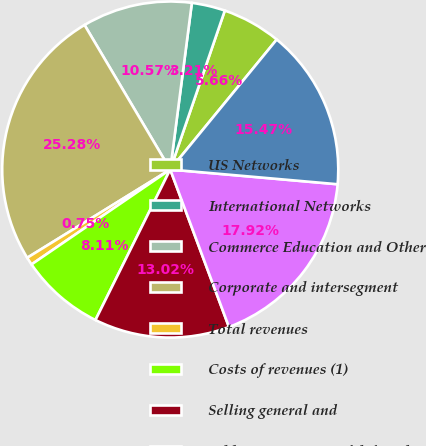<chart> <loc_0><loc_0><loc_500><loc_500><pie_chart><fcel>US Networks<fcel>International Networks<fcel>Commerce Education and Other<fcel>Corporate and intersegment<fcel>Total revenues<fcel>Costs of revenues (1)<fcel>Selling general and<fcel>Add Amortization of deferred<fcel>Adjusted OIBDA<nl><fcel>5.66%<fcel>3.21%<fcel>10.57%<fcel>25.28%<fcel>0.75%<fcel>8.11%<fcel>13.02%<fcel>17.92%<fcel>15.47%<nl></chart> 